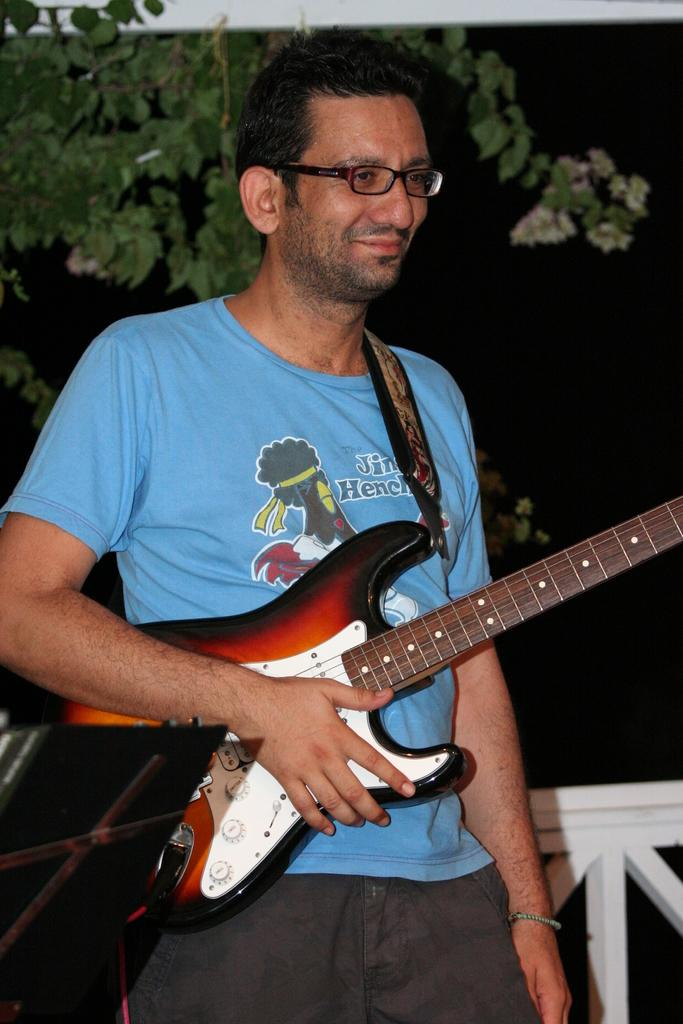Who is present in the image? There is a person in the image. What is the person wearing? The person is wearing a blue shirt. What is the person holding in the image? The person is holding a guitar. What can be seen in the background of the image? There is a tree in the background of the image. What type of hair is the person in the image using to play the guitar? The person in the image is not using hair to play the guitar; they are using their hands. 